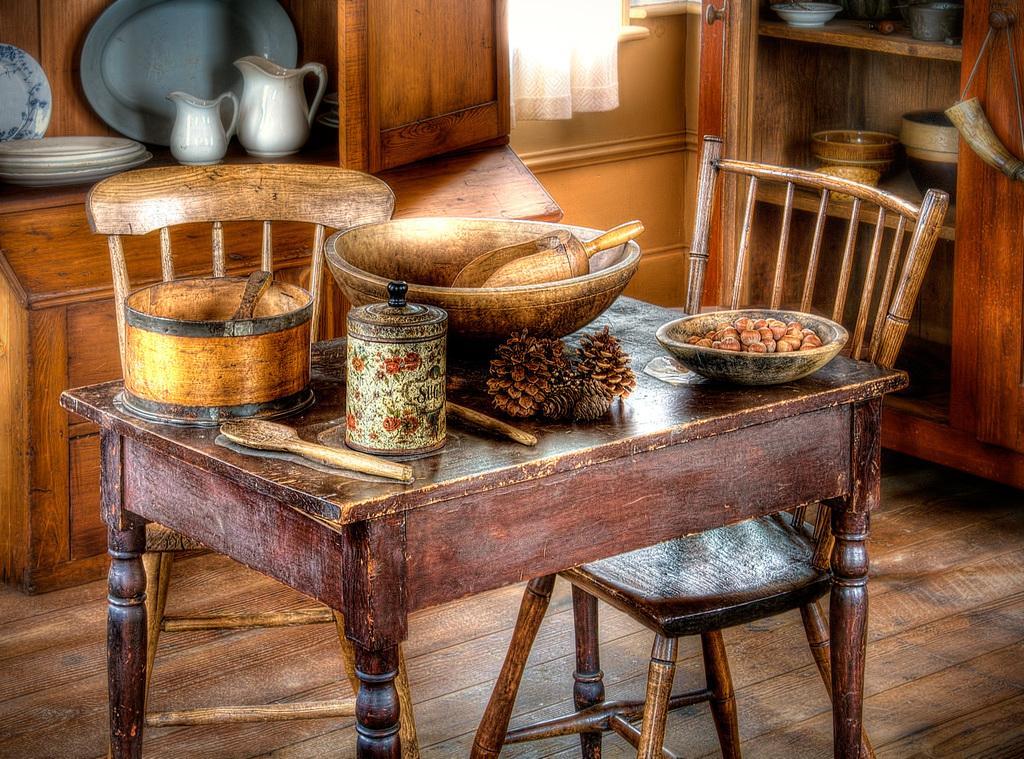Describe this image in one or two sentences. In this picture there are several food items and containers are kept on top of a table. Everything in this picture is brown in color. 